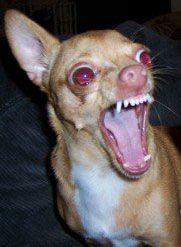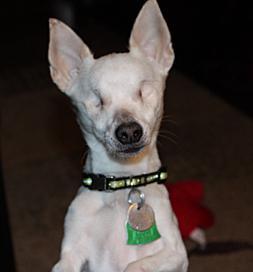The first image is the image on the left, the second image is the image on the right. Analyze the images presented: Is the assertion "One of the dogs in one of the images is baring its teeth." valid? Answer yes or no. Yes. 